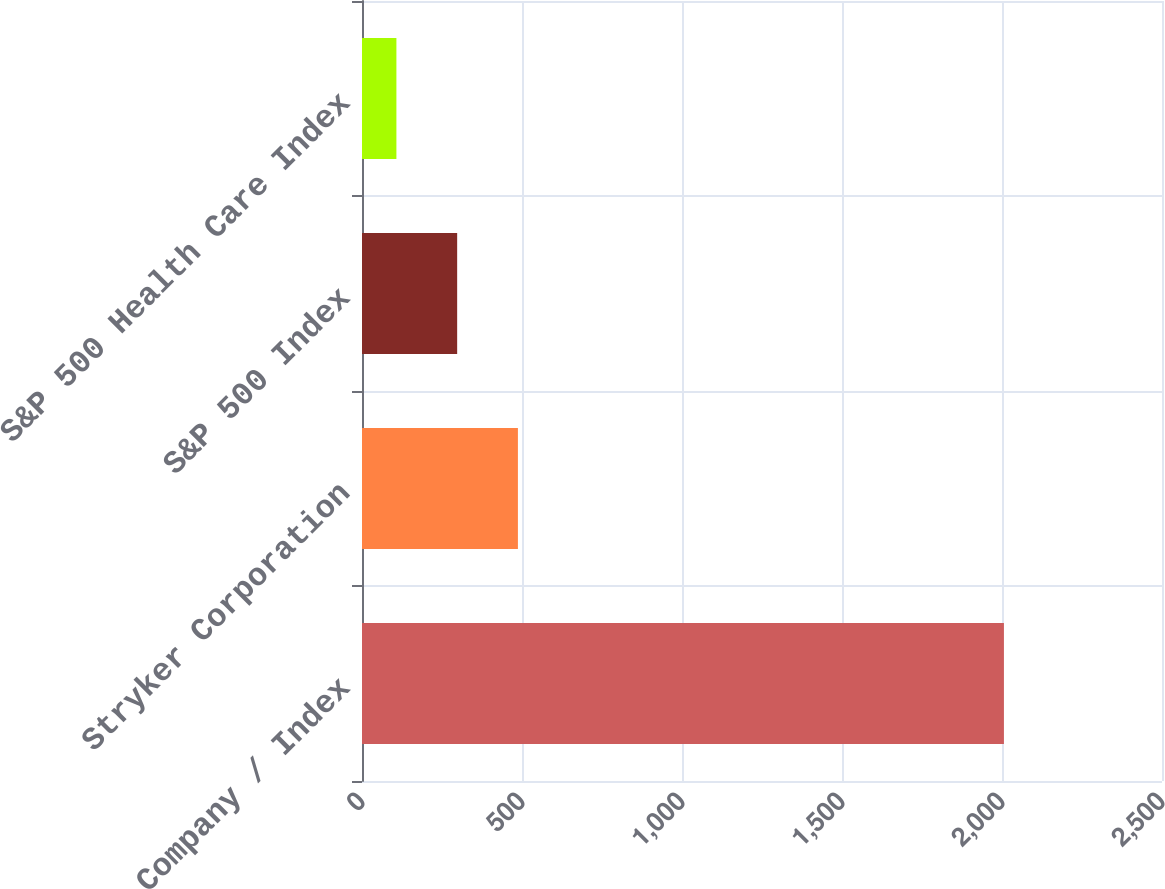Convert chart to OTSL. <chart><loc_0><loc_0><loc_500><loc_500><bar_chart><fcel>Company / Index<fcel>Stryker Corporation<fcel>S&P 500 Index<fcel>S&P 500 Health Care Index<nl><fcel>2006<fcel>487.23<fcel>297.38<fcel>107.53<nl></chart> 